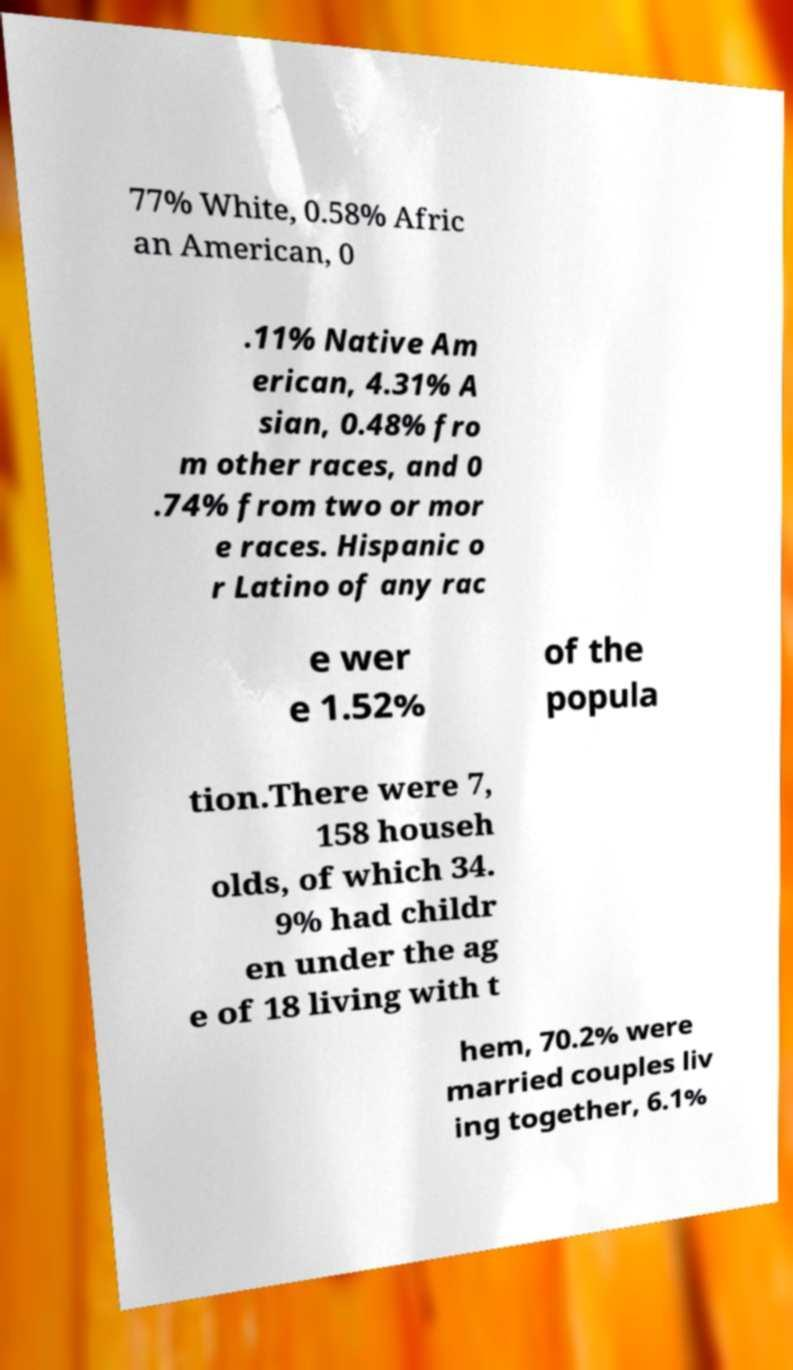Please identify and transcribe the text found in this image. 77% White, 0.58% Afric an American, 0 .11% Native Am erican, 4.31% A sian, 0.48% fro m other races, and 0 .74% from two or mor e races. Hispanic o r Latino of any rac e wer e 1.52% of the popula tion.There were 7, 158 househ olds, of which 34. 9% had childr en under the ag e of 18 living with t hem, 70.2% were married couples liv ing together, 6.1% 